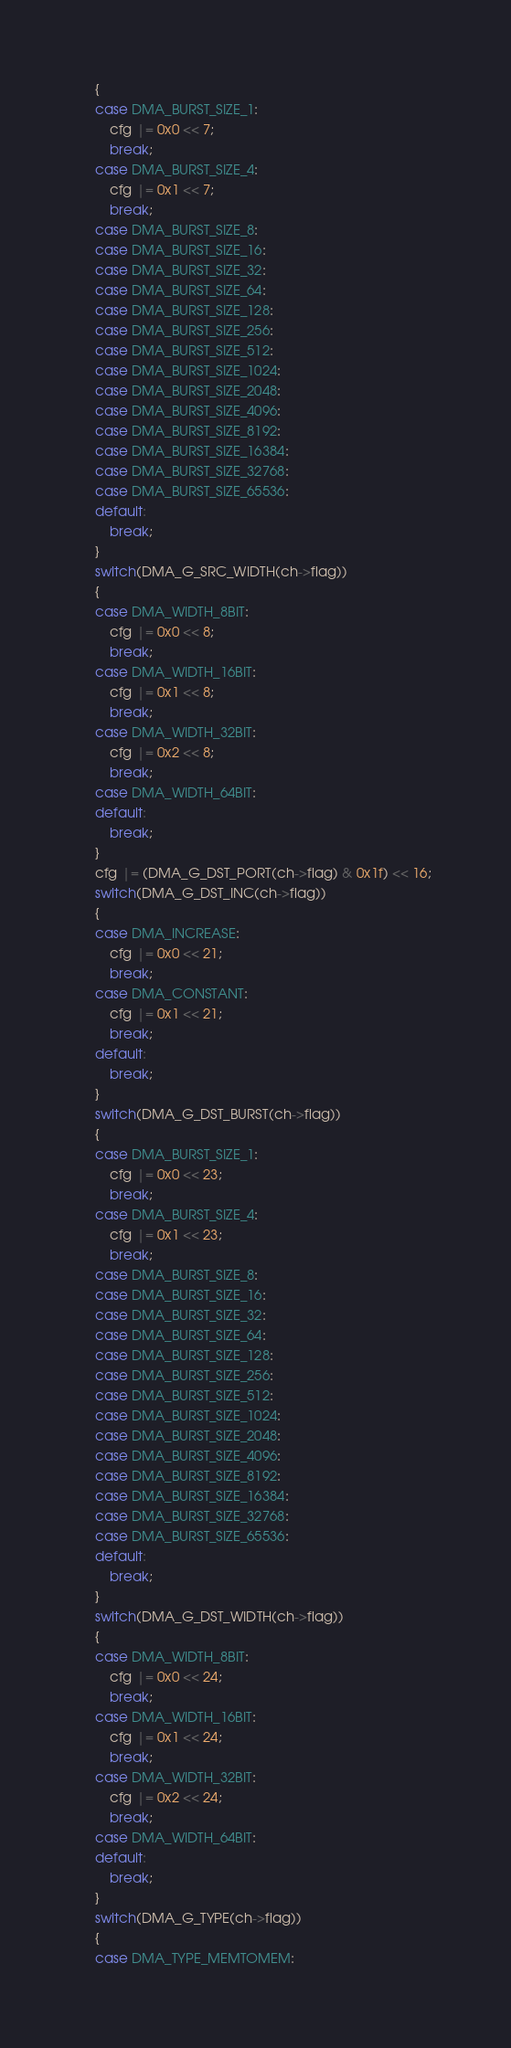Convert code to text. <code><loc_0><loc_0><loc_500><loc_500><_C_>	{
	case DMA_BURST_SIZE_1:
		cfg |= 0x0 << 7;
		break;
	case DMA_BURST_SIZE_4:
		cfg |= 0x1 << 7;
		break;
	case DMA_BURST_SIZE_8:
	case DMA_BURST_SIZE_16:
	case DMA_BURST_SIZE_32:
	case DMA_BURST_SIZE_64:
	case DMA_BURST_SIZE_128:
	case DMA_BURST_SIZE_256:
	case DMA_BURST_SIZE_512:
	case DMA_BURST_SIZE_1024:
	case DMA_BURST_SIZE_2048:
	case DMA_BURST_SIZE_4096:
	case DMA_BURST_SIZE_8192:
	case DMA_BURST_SIZE_16384:
	case DMA_BURST_SIZE_32768:
	case DMA_BURST_SIZE_65536:
	default:
		break;
	}
	switch(DMA_G_SRC_WIDTH(ch->flag))
	{
	case DMA_WIDTH_8BIT:
		cfg |= 0x0 << 8;
		break;
	case DMA_WIDTH_16BIT:
		cfg |= 0x1 << 8;
		break;
	case DMA_WIDTH_32BIT:
		cfg |= 0x2 << 8;
		break;
	case DMA_WIDTH_64BIT:
	default:
		break;
	}
	cfg |= (DMA_G_DST_PORT(ch->flag) & 0x1f) << 16;
	switch(DMA_G_DST_INC(ch->flag))
	{
	case DMA_INCREASE:
		cfg |= 0x0 << 21;
		break;
	case DMA_CONSTANT:
		cfg |= 0x1 << 21;
		break;
	default:
		break;
	}
	switch(DMA_G_DST_BURST(ch->flag))
	{
	case DMA_BURST_SIZE_1:
		cfg |= 0x0 << 23;
		break;
	case DMA_BURST_SIZE_4:
		cfg |= 0x1 << 23;
		break;
	case DMA_BURST_SIZE_8:
	case DMA_BURST_SIZE_16:
	case DMA_BURST_SIZE_32:
	case DMA_BURST_SIZE_64:
	case DMA_BURST_SIZE_128:
	case DMA_BURST_SIZE_256:
	case DMA_BURST_SIZE_512:
	case DMA_BURST_SIZE_1024:
	case DMA_BURST_SIZE_2048:
	case DMA_BURST_SIZE_4096:
	case DMA_BURST_SIZE_8192:
	case DMA_BURST_SIZE_16384:
	case DMA_BURST_SIZE_32768:
	case DMA_BURST_SIZE_65536:
	default:
		break;
	}
	switch(DMA_G_DST_WIDTH(ch->flag))
	{
	case DMA_WIDTH_8BIT:
		cfg |= 0x0 << 24;
		break;
	case DMA_WIDTH_16BIT:
		cfg |= 0x1 << 24;
		break;
	case DMA_WIDTH_32BIT:
		cfg |= 0x2 << 24;
		break;
	case DMA_WIDTH_64BIT:
	default:
		break;
	}
	switch(DMA_G_TYPE(ch->flag))
	{
	case DMA_TYPE_MEMTOMEM:</code> 